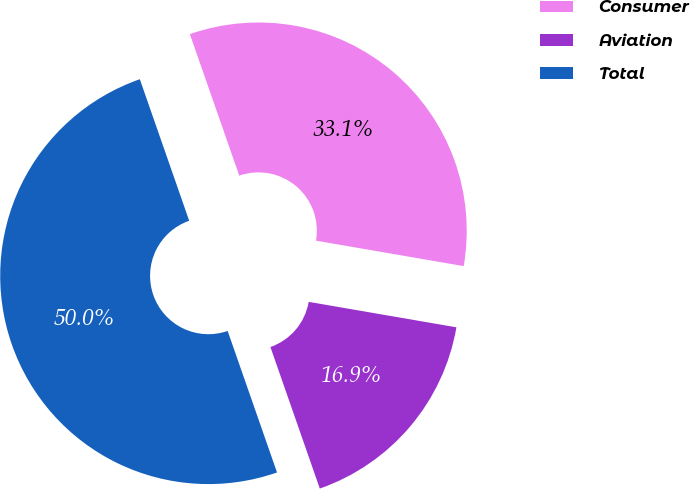Convert chart to OTSL. <chart><loc_0><loc_0><loc_500><loc_500><pie_chart><fcel>Consumer<fcel>Aviation<fcel>Total<nl><fcel>33.06%<fcel>16.94%<fcel>50.0%<nl></chart> 